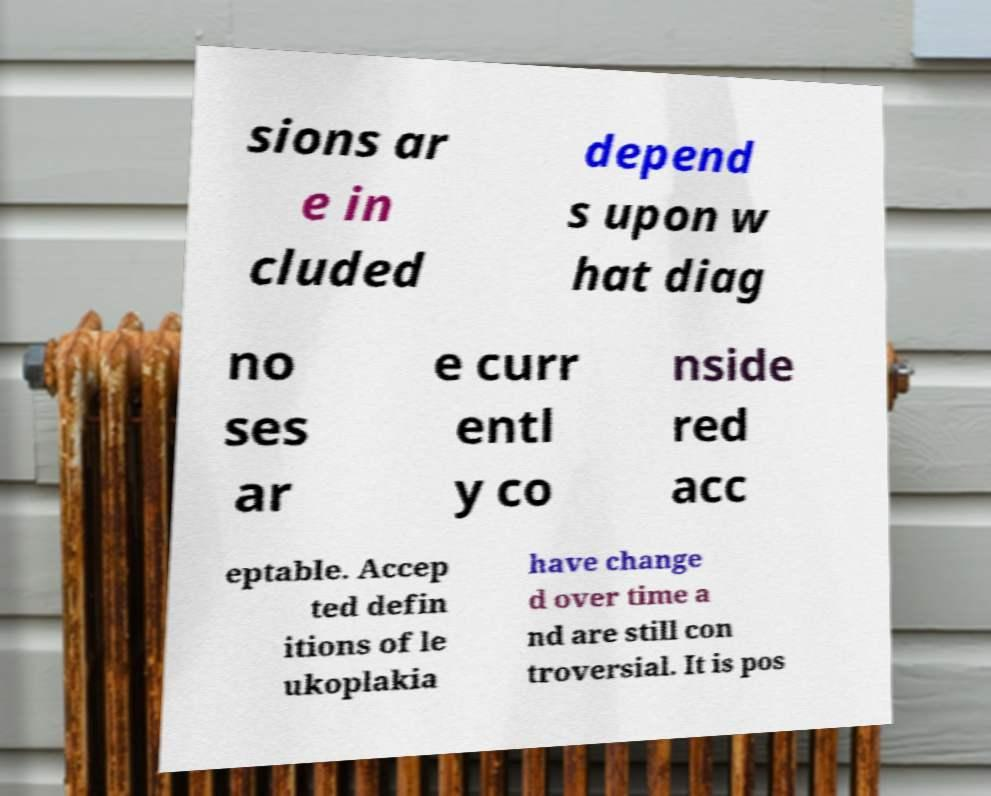Please identify and transcribe the text found in this image. sions ar e in cluded depend s upon w hat diag no ses ar e curr entl y co nside red acc eptable. Accep ted defin itions of le ukoplakia have change d over time a nd are still con troversial. It is pos 